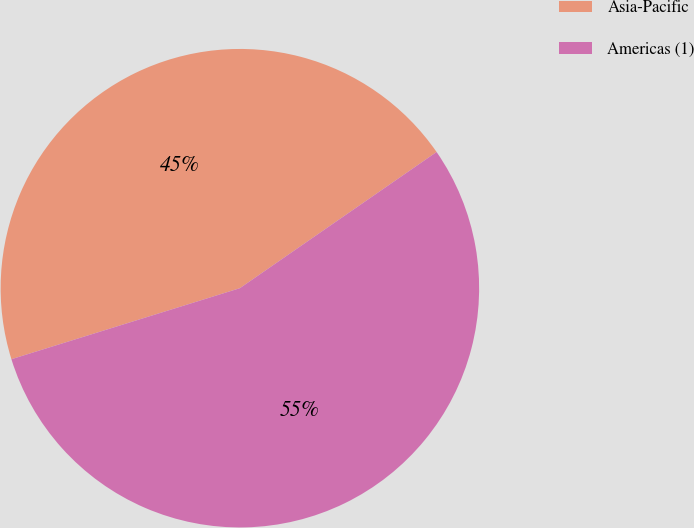Convert chart. <chart><loc_0><loc_0><loc_500><loc_500><pie_chart><fcel>Asia-Pacific<fcel>Americas (1)<nl><fcel>45.16%<fcel>54.84%<nl></chart> 